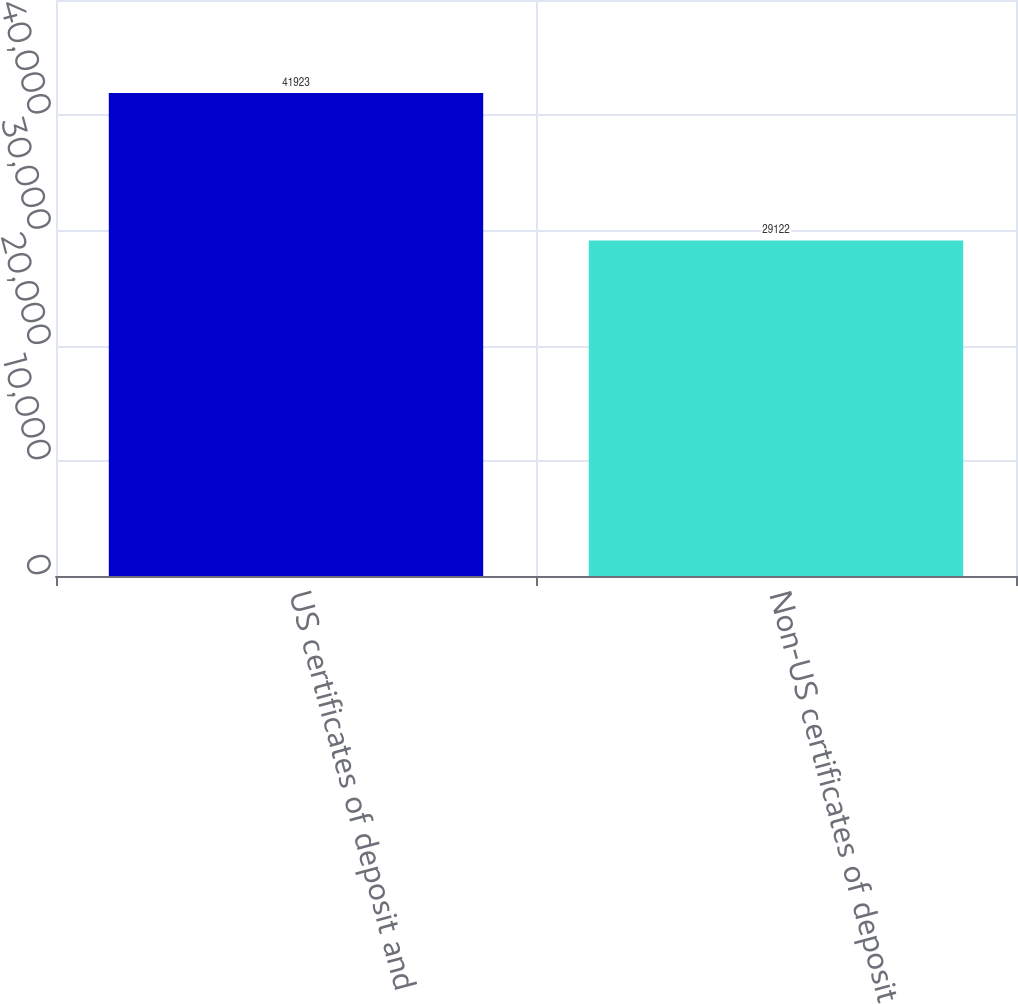<chart> <loc_0><loc_0><loc_500><loc_500><bar_chart><fcel>US certificates of deposit and<fcel>Non-US certificates of deposit<nl><fcel>41923<fcel>29122<nl></chart> 